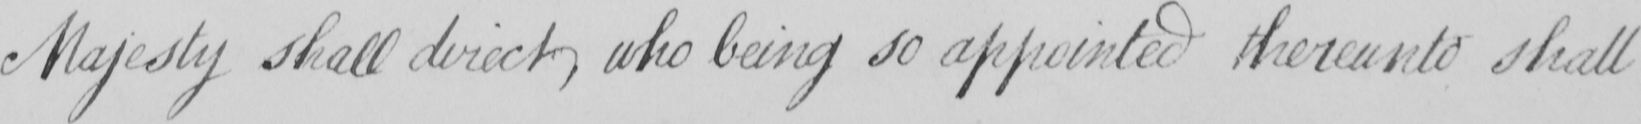Can you tell me what this handwritten text says? Majesty shall direct , who being so appointed thereunto shall 